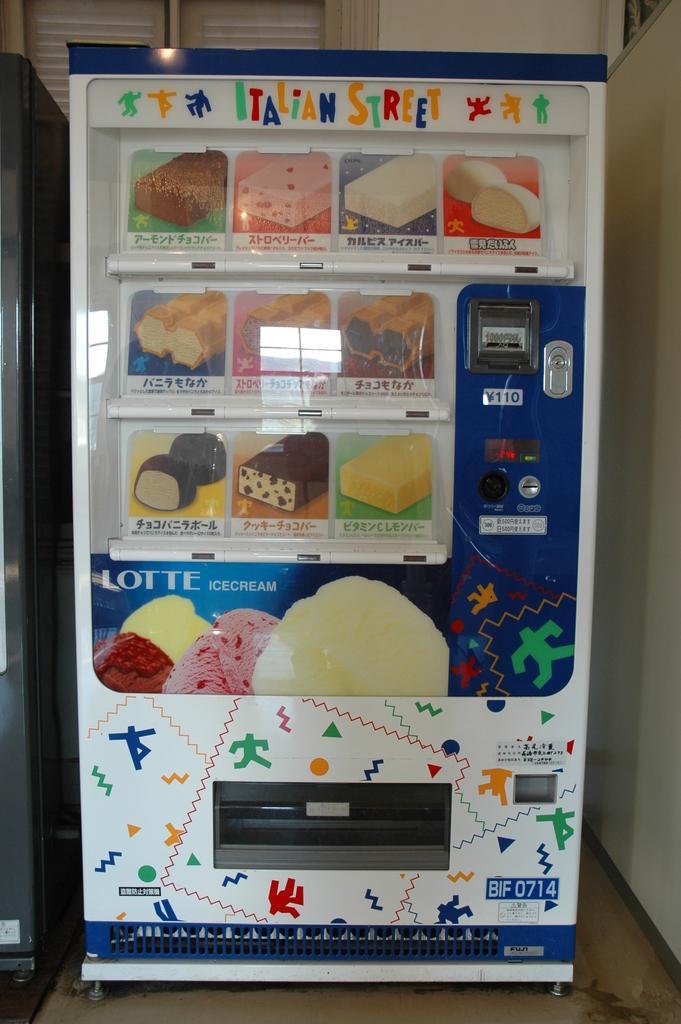Describe this image in one or two sentences. This is a vending machine and there are some food items in this machine and here is a chocolate and this is a cake and there are some items all over the machine. Here is the place where we have to insert our currency and here is the place we have to collect your selected food item in the machine. The machine is placed on the floor, beside the machine there is a wall. Behind this machine a window is located. 